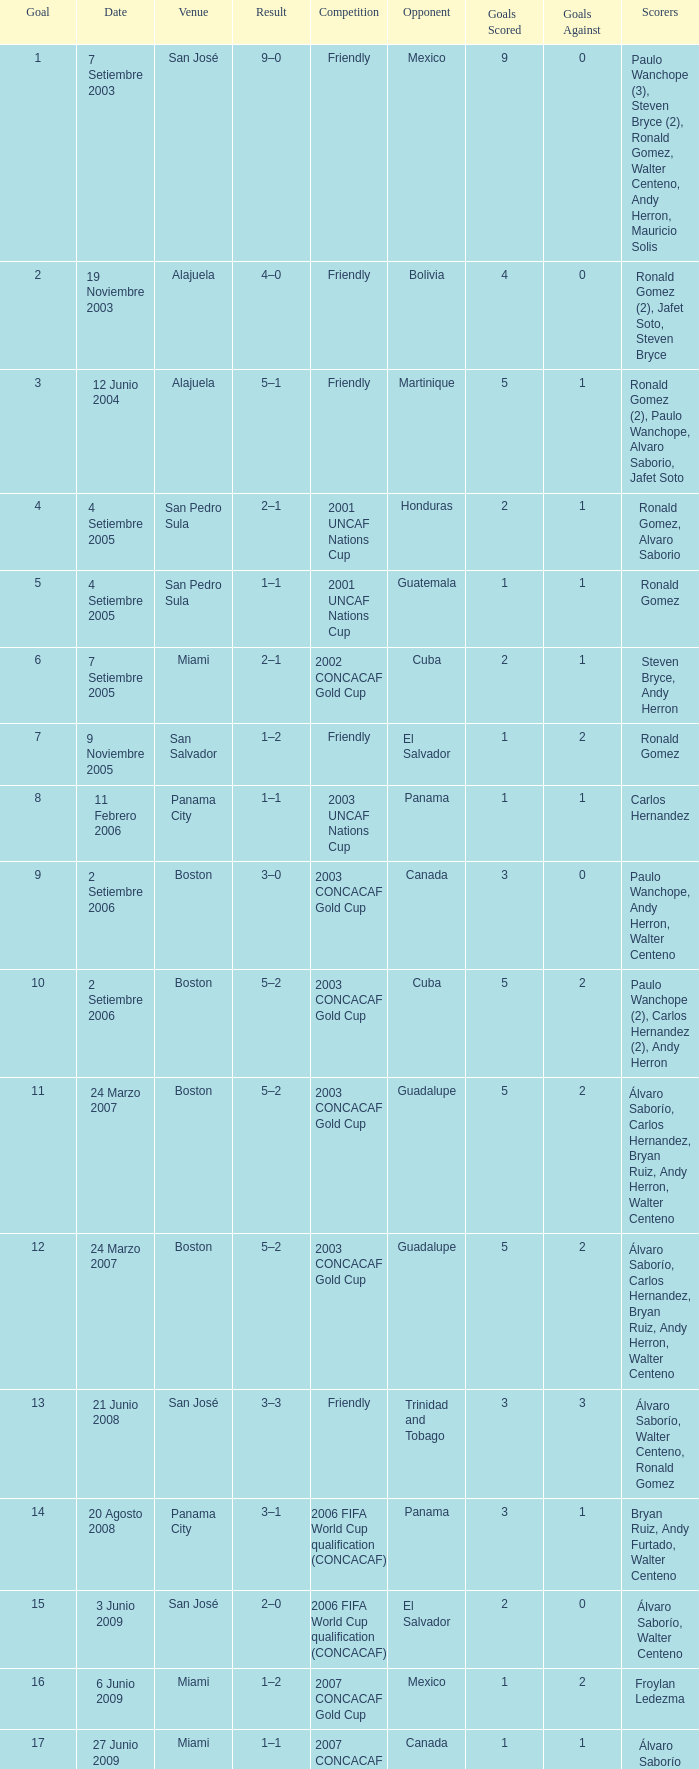At the venue of panama city, on 11 Febrero 2006, how many goals were scored? 1.0. 